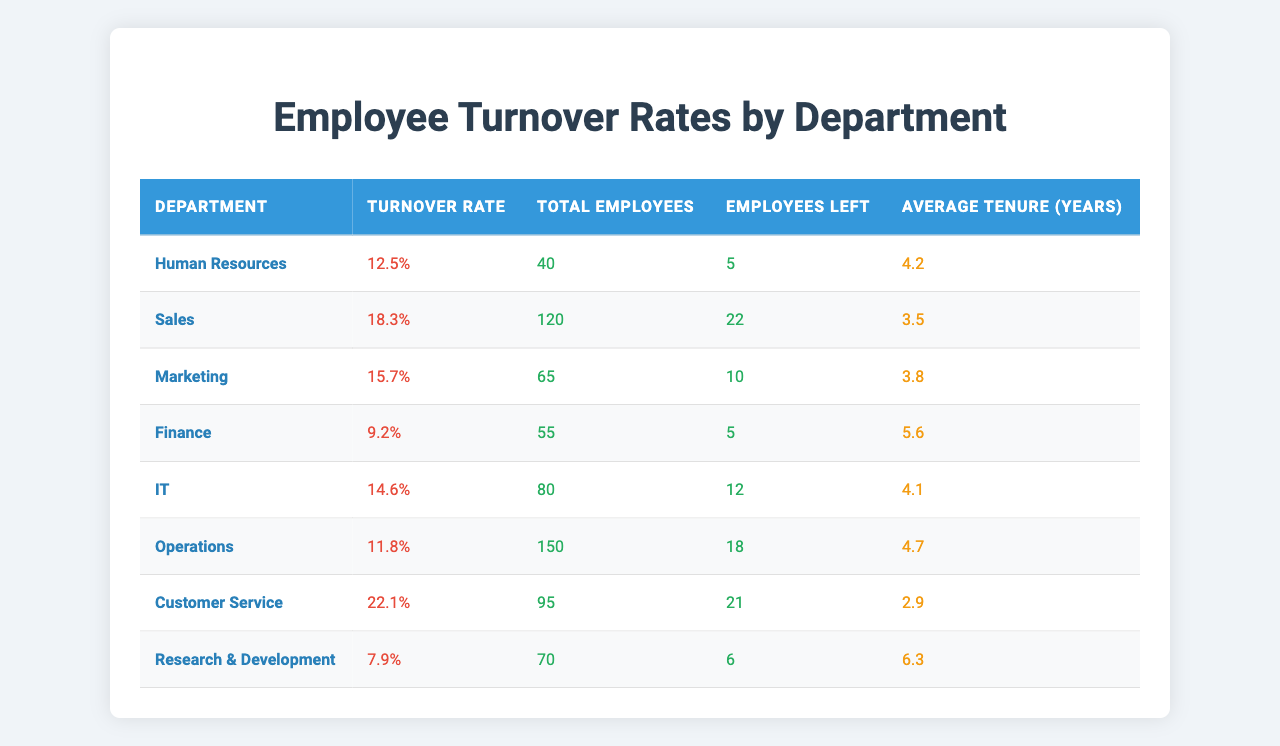What is the turnover rate for the Finance department? The table shows the turnover rate for the Finance department as 9.2%.
Answer: 9.2% Which department has the highest turnover rate? The table indicates that the Customer Service department has the highest turnover rate at 22.1%.
Answer: Customer Service How many employees left in the Sales department? The table states that 22 employees left the Sales department.
Answer: 22 What is the average tenure for employees in the Marketing department? According to the table, the average tenure for employees in the Marketing department is 3.8 years.
Answer: 3.8 years What is the total number of employees across all departments? To find the total, we sum the total employees column: 40 + 120 + 65 + 55 + 80 + 150 + 95 + 70 = 670.
Answer: 670 What is the average turnover rate for all departments? The average turnover rate is calculated by summing all turnover rates (12.5 + 18.3 + 15.7 + 9.2 + 14.6 + 11.8 + 22.1 + 7.9) = 112.1 and dividing by the number of departments (8), which gives 112.1 / 8 = 14.01.
Answer: 14.01% Is the turnover rate for the IT department above or below the overall average turnover rate? The IT department’s turnover rate is 14.6%, and the overall average turnover rate is 14.01%, so IT is above the average.
Answer: Above Which department has the lowest average tenure, and what is that tenure? The table shows that the Customer Service department has the lowest average tenure of 2.9 years.
Answer: Customer Service, 2.9 years If we combine the turnover rates for the Human Resources and Operations departments, what is the total turnover rate? The combined turnover rates are (12.5 + 11.8) = 24.3%. There are 2 departments, so the average turnover rate is 24.3 / 2 = 12.15%.
Answer: 12.15% How many more employees left in Customer Service than in Finance? Customer Service had 21 employees leave, and Finance had 5 employees leave, so the difference is 21 - 5 = 16.
Answer: 16 What percentage of employees left in the IT department? To find the percentage, divide the number of employees left (12) by the total number of employees (80) and multiply by 100: (12/80) * 100 = 15%.
Answer: 15% 